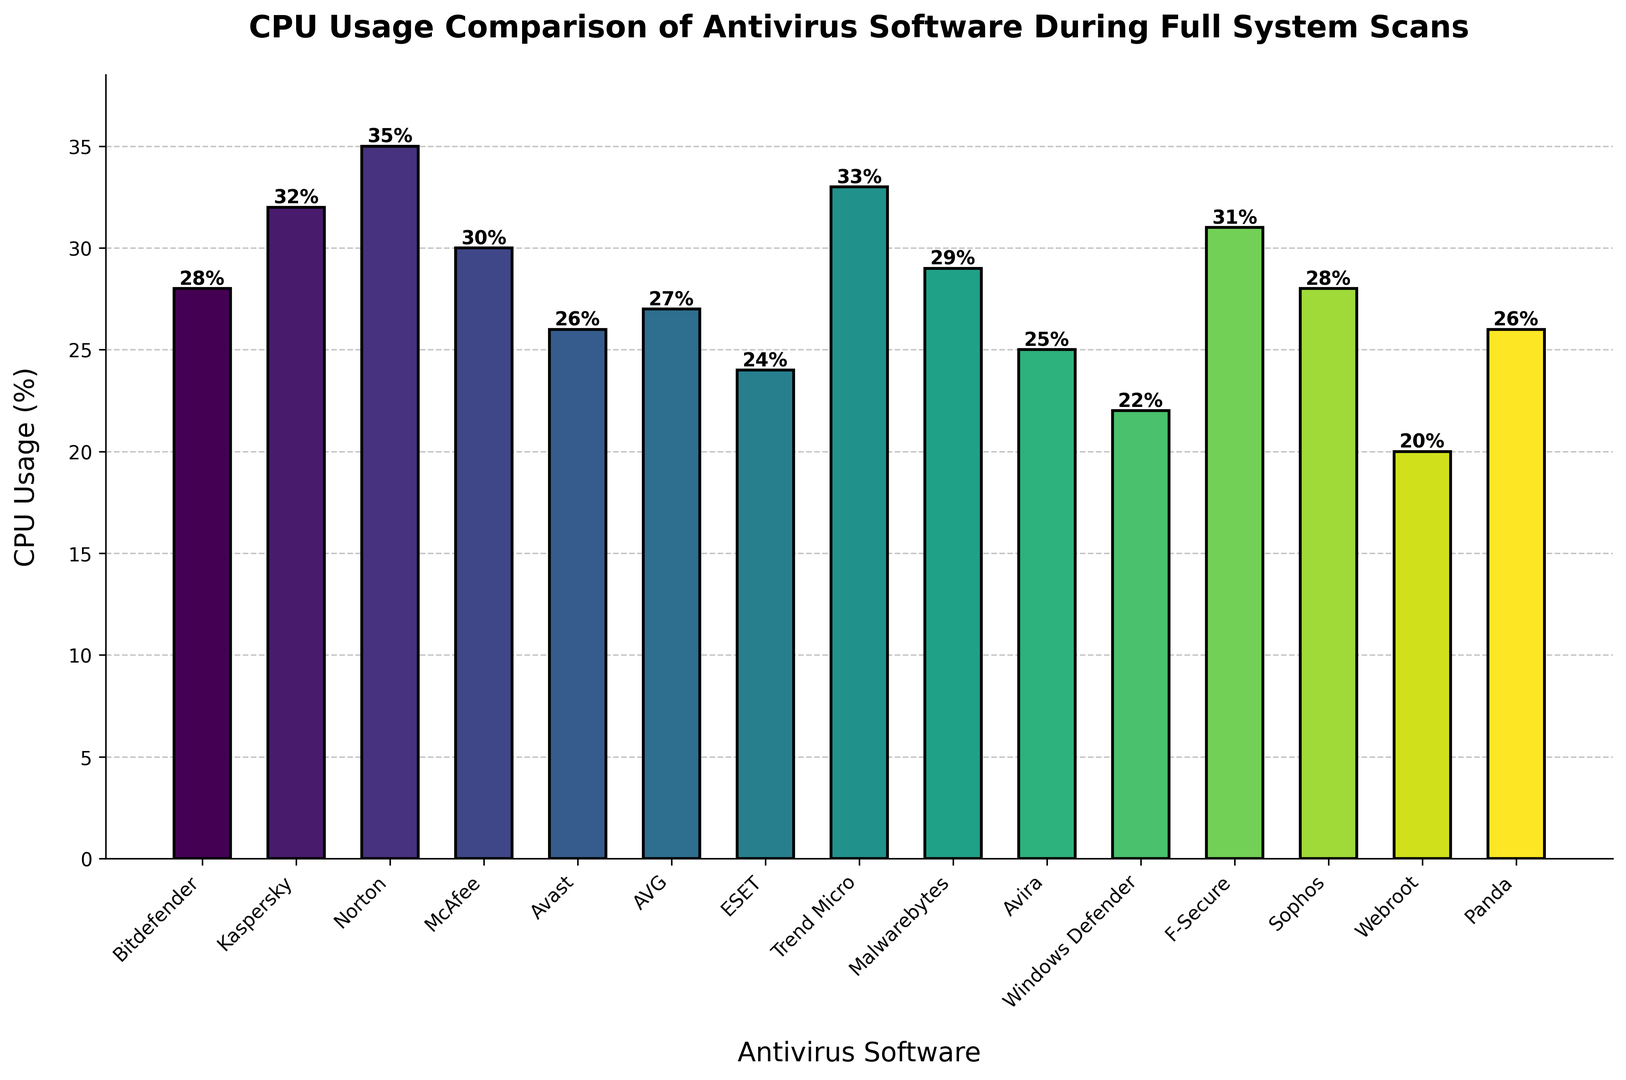Which antivirus software has the lowest CPU usage during a full system scan? To determine which software has the lowest CPU usage, look at the heights of the bars and identify the shortest bar. The shortest bar corresponds to Webroot with a CPU usage of 20%.
Answer: Webroot Which two antivirus software programs have the same CPU usage? Examine the heights of the bars and see which bars have the same height or labeled percentage. Both Bitdefender and Sophos show a CPU usage of 28%.
Answer: Bitdefender and Sophos What is the difference in CPU usage between Norton and Windows Defender? Subtract the CPU usage percentage of Windows Defender from that of Norton. Norton has 35%, and Windows Defender has 22%, so the difference is 35% - 22% = 13%.
Answer: 13% Which antivirus software has a CPU usage lower than 25%? Identify the bars representing CPU usage percentages less than 25%. Webroot (20%), ESET (24%), and Windows Defender (22%) all have CPU usage below 25%.
Answer: Webroot, ESET, Windows Defender How many antivirus software programs have a CPU usage greater than 30%? Count the number of bars that exceed the 30% CPU usage mark. There are four: Kaspersky (32%), Norton (35%), Trend Micro (33%), and F-Secure (31%).
Answer: 4 What is the average CPU usage of Avast, AVG, and Panda? Calculate the mean of their respective CPU usage percentages. Avast (26%), AVG (27%), and Panda (26%) add up to 26 + 27 + 26 = 79. The average is 79/3 = 26.33%.
Answer: 26.33% Which antivirus software shows the highest CPU usage, and what is its value? Find the tallest bar on the chart, which corresponds to Norton with a CPU usage of 35%.
Answer: Norton, 35% Order the following antivirus software programs from lowest to highest CPU usage: Bitdefender, McAfee, Avira, Malwarebytes. Compare their CPU usages: Bitdefender (28%), McAfee (30%), Avira (25%), Malwarebytes (29%). The order is Avira (25%), Bitdefender (28%), Malwarebytes (29%), McAfee (30%).
Answer: Avira, Bitdefender, Malwarebytes, McAfee What is the total CPU usage percentage of Bitdefender, Kaspersky, and Norton combined? Add the CPU usage percentages of Bitdefender (28%), Kaspersky (32%), and Norton (35%). The total is 28 + 32 + 35 = 95%.
Answer: 95% What percentage of antivirus software has CPU usage below 30%? First, count the total number of antivirus software (15). Next, count those with CPU usage below 30%: Bitdefender (28%), Avast (26%), AVG (27%), ESET (24%), Malwarebytes (29%), Avira (25%), Webroot (20%), Windows Defender (22%), Panda (26%). There are 9 out of 15. The percentage is (9/15) * 100 = 60%.
Answer: 60% 